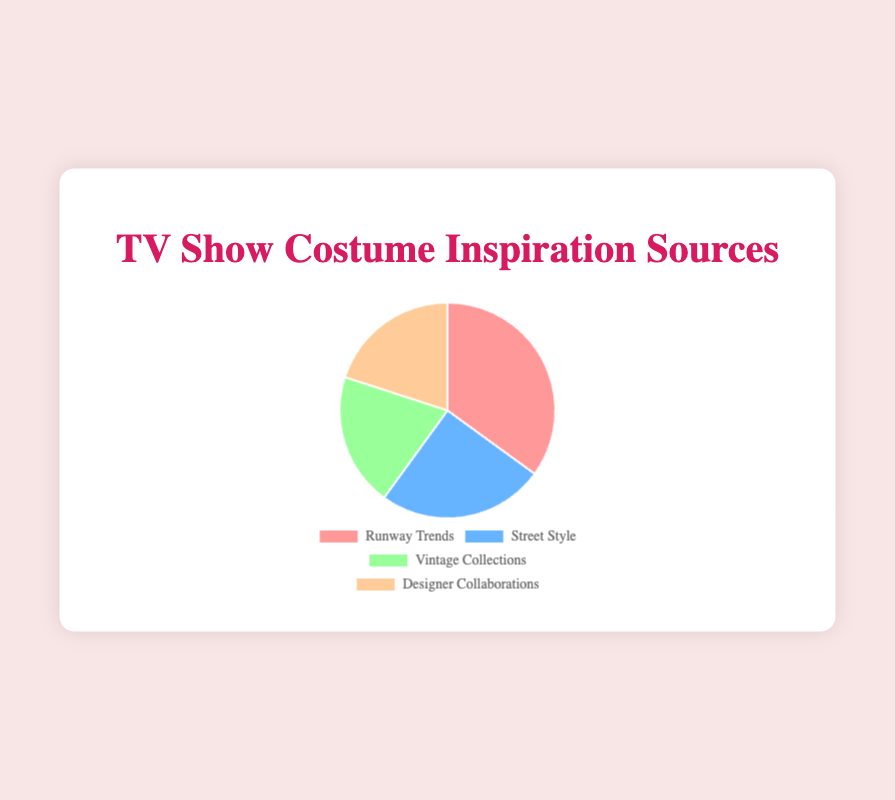What's the main source of fashion inspiration for TV show costumes? The pie chart shows that Runway Trends holds the largest percentage of fashion inspiration sources for TV show costumes, which is 35%.
Answer: Runway Trends Which two sources of fashion inspiration hold the same percentage? By looking at the pie chart, we can identify that Vintage Collections and Designer Collaborations both share the same percentage, which is 20%.
Answer: Vintage Collections and Designer Collaborations What is the combined percentage of Street Style and Designer Collaborations? Adding the percentages for Street Style (25%) and Designer Collaborations (20%) gives 25% + 20% which equals 45%.
Answer: 45% How does the percentage of Vintage Collections compare to Runway Trends? Runway Trends has 35% while Vintage Collections has 20%, therefore Runway Trends is 15% greater than Vintage Collections.
Answer: Runway Trends is 15% greater What color represents the category with the smallest percentage? From the pie chart, both Vintage Collections and Designer Collaborations have the smallest percentages at 20%. The colors representing these categories are green and orange respectively.
Answer: Green and Orange Which inspiration source is depicted in blue? The pie chart reveals that the blue section represents Street Style.
Answer: Street Style Is the percentage of Designer Collaborations greater than Street Style? By checking the pie chart, Designer Collaborations has 20% while Street Style has 25%, so Designer Collaborations is not greater than Street Style.
Answer: No What is the average percentage of all the sources? Summing all the percentages: 35% (Runway Trends) + 25% (Street Style) + 20% (Vintage Collections) + 20% (Designer Collaborations) equals 100%. Dividing by the 4 sources gives an average percentage of 25%.
Answer: 25% Which inspiration sources together make up 40% of the total? By observing the pie chart, the combination of Vintage Collections (20%) and Designer Collaborations (20%) gives a total of 40%.
Answer: Vintage Collections and Designer Collaborations 